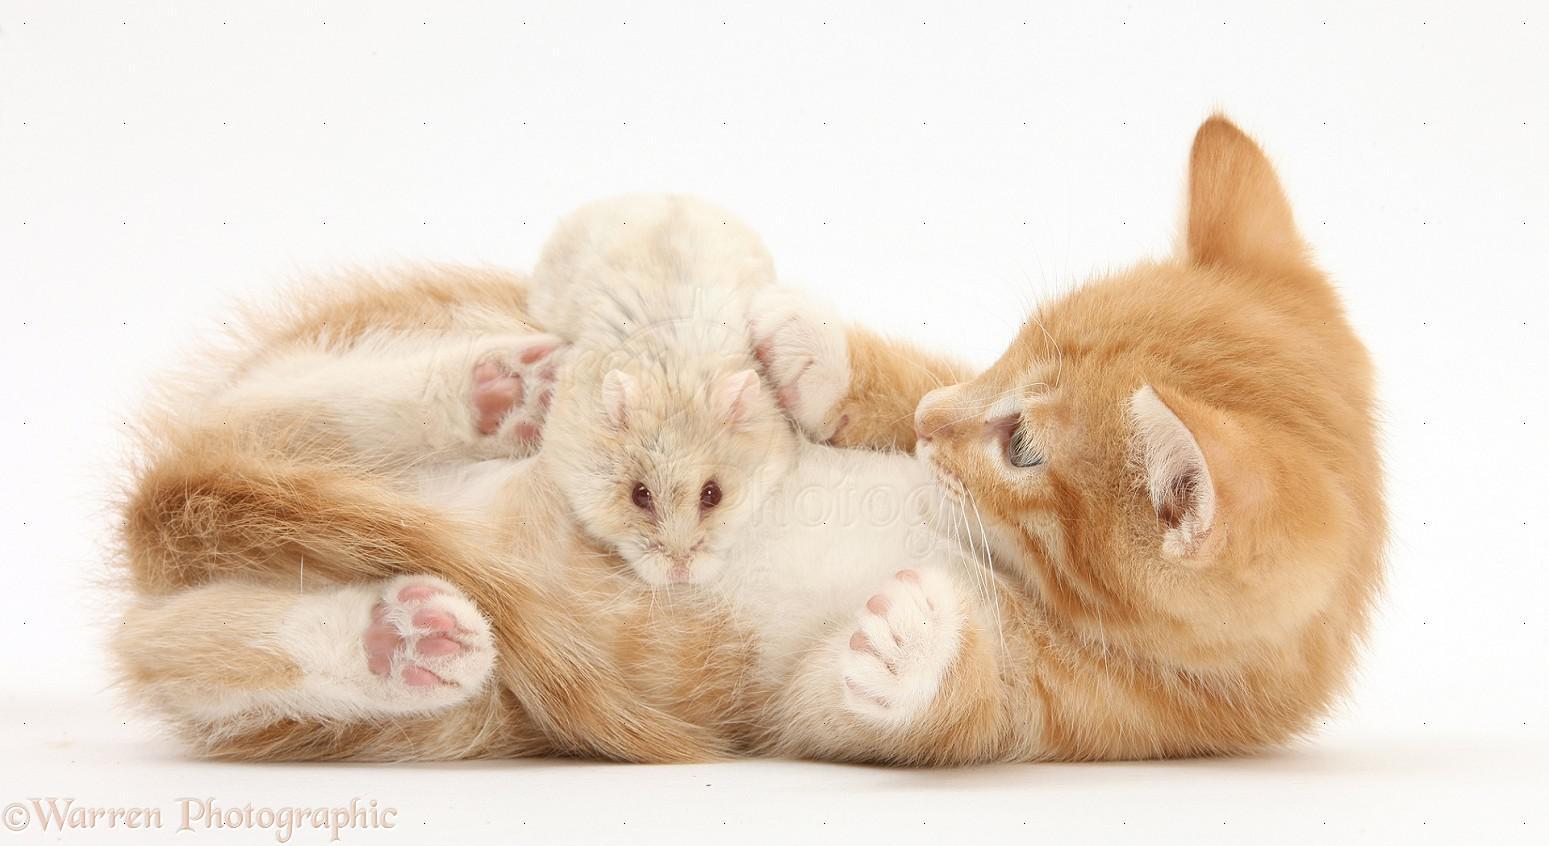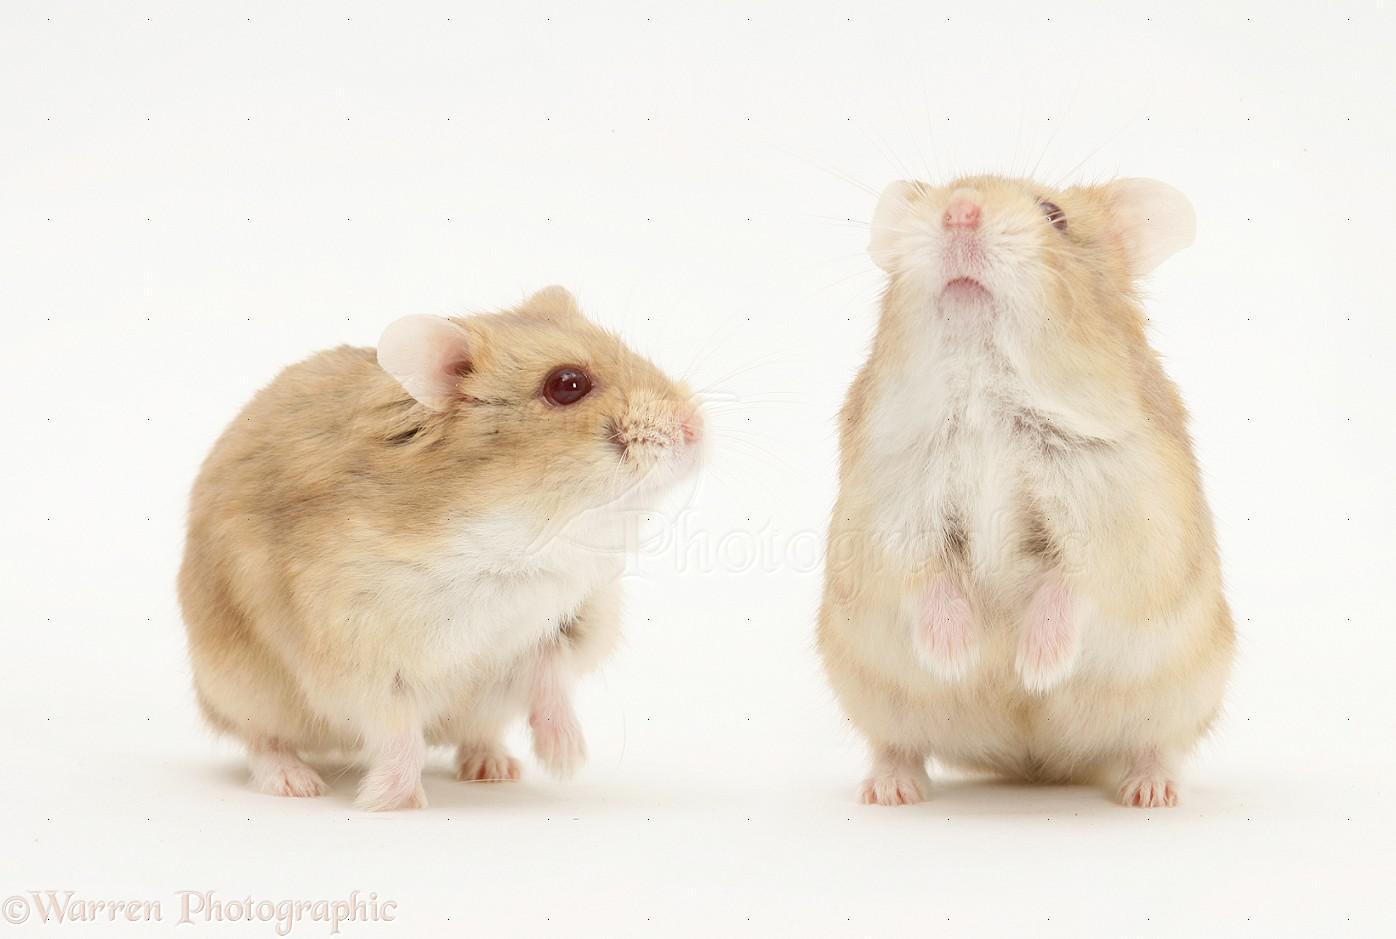The first image is the image on the left, the second image is the image on the right. Examine the images to the left and right. Is the description "The right image contains exactly two rodents." accurate? Answer yes or no. Yes. The first image is the image on the left, the second image is the image on the right. Evaluate the accuracy of this statement regarding the images: "At least one image shows a small pet rodent posed with a larger pet animal on a white background.". Is it true? Answer yes or no. Yes. 